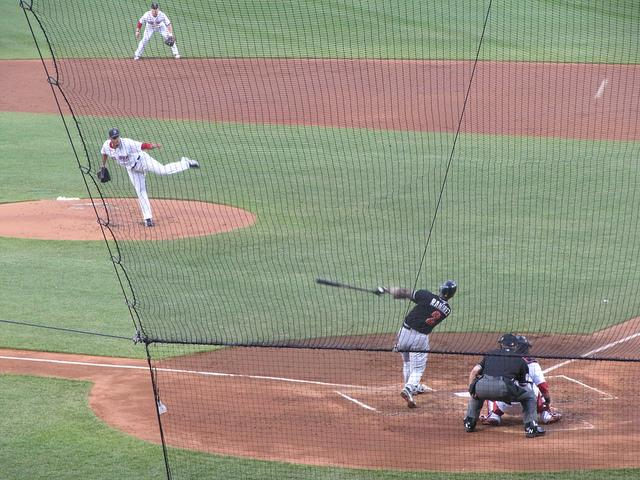What is the position of the player in the middle of the field?

Choices:
A) first baseman
B) pitcher
C) outfielder
D) shortstop pitcher 